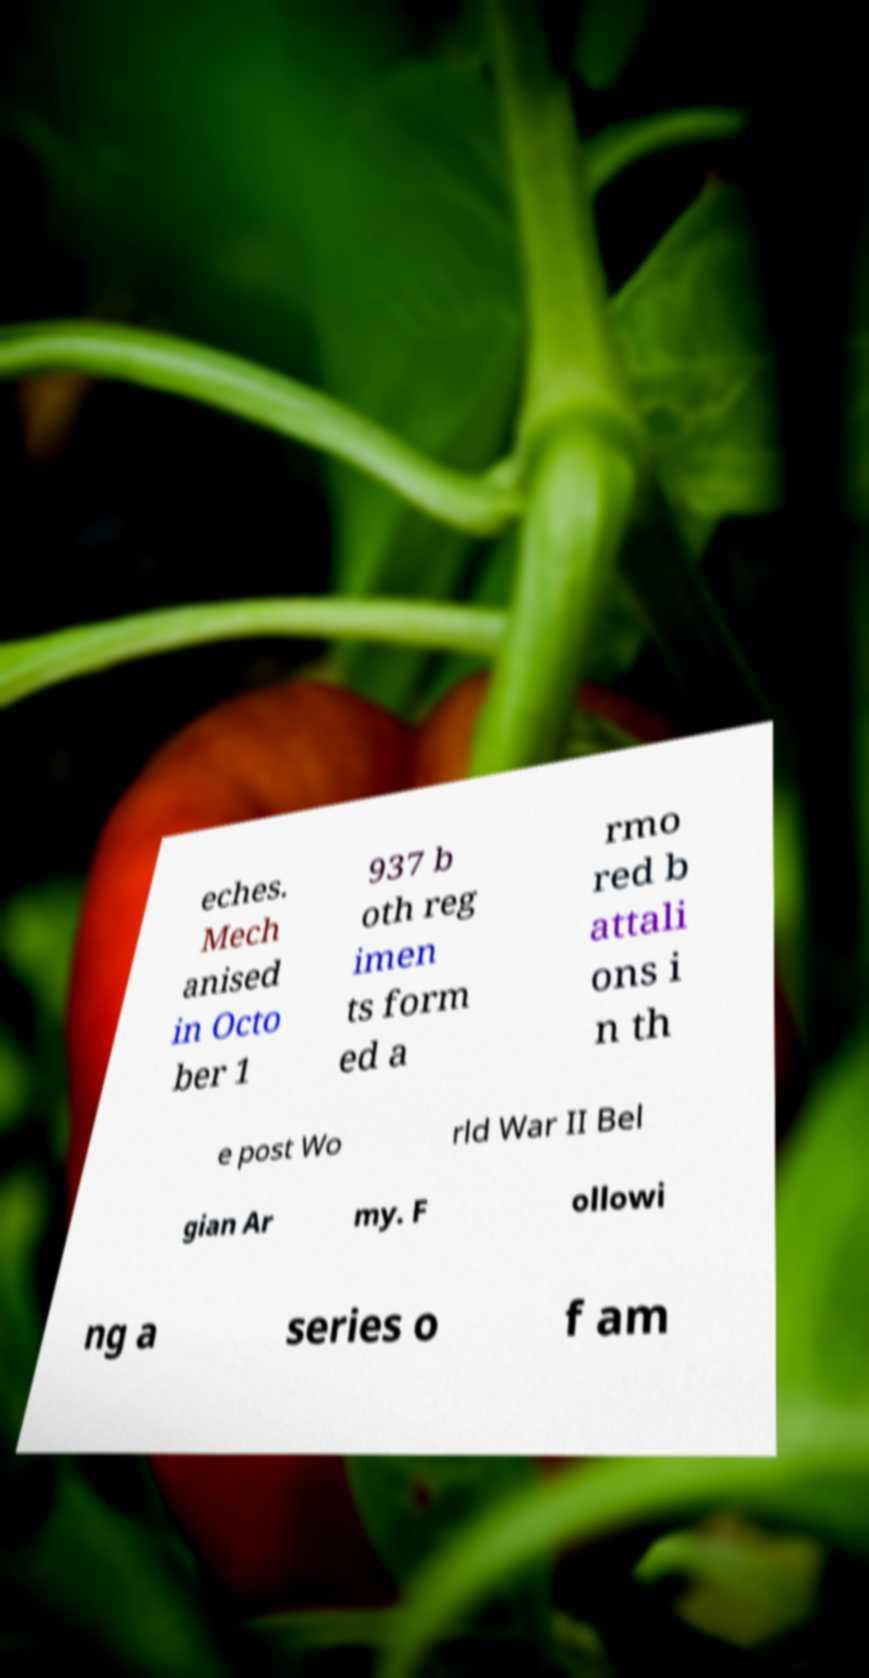There's text embedded in this image that I need extracted. Can you transcribe it verbatim? eches. Mech anised in Octo ber 1 937 b oth reg imen ts form ed a rmo red b attali ons i n th e post Wo rld War II Bel gian Ar my. F ollowi ng a series o f am 